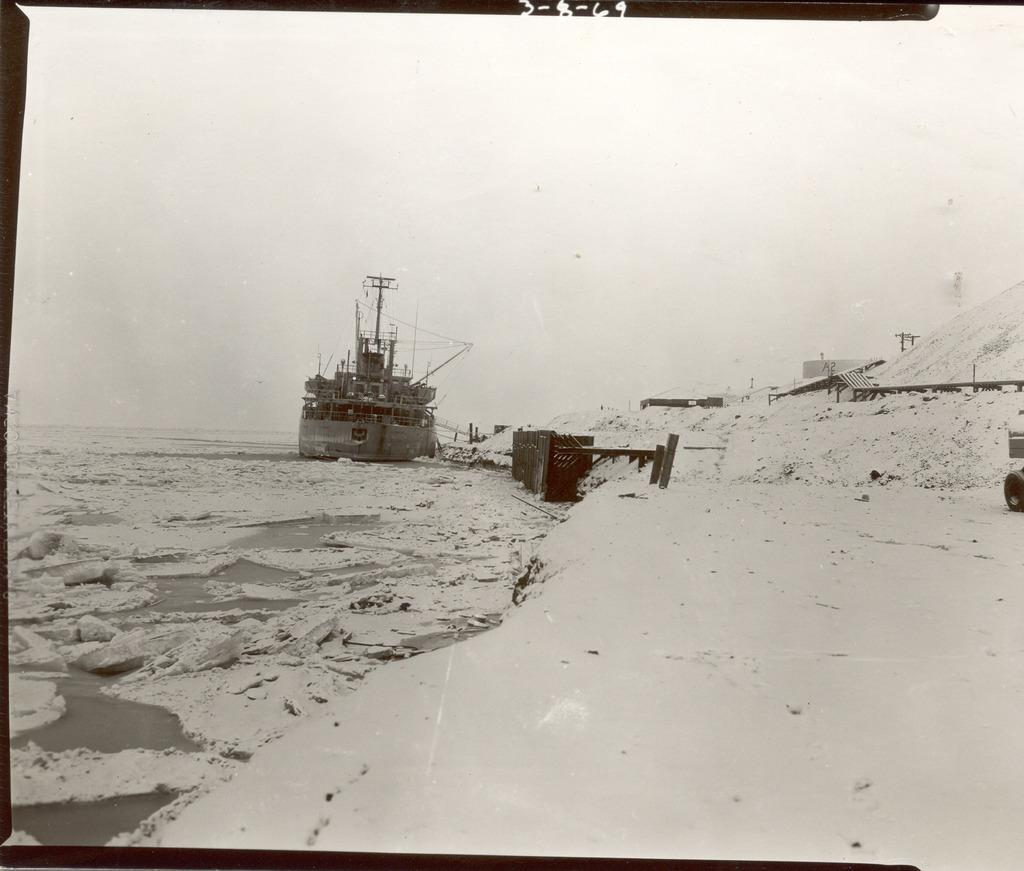What is the main subject of the image? The main subject of the image is a ship. Where is the ship located in the image? The ship is on the water in the image. What other structures can be seen in the image? There are sheds in the image. What is the color scheme of the image? The image is in black and white. Can you see a farmer working in harmony with the ship in the image? There is no farmer or any indication of harmony with the ship in the image; it only features a ship on the water and sheds in the background. Is there a hose attached to the ship in the image? There is no hose visible in the image; it only shows a ship on the water and sheds in the background. 